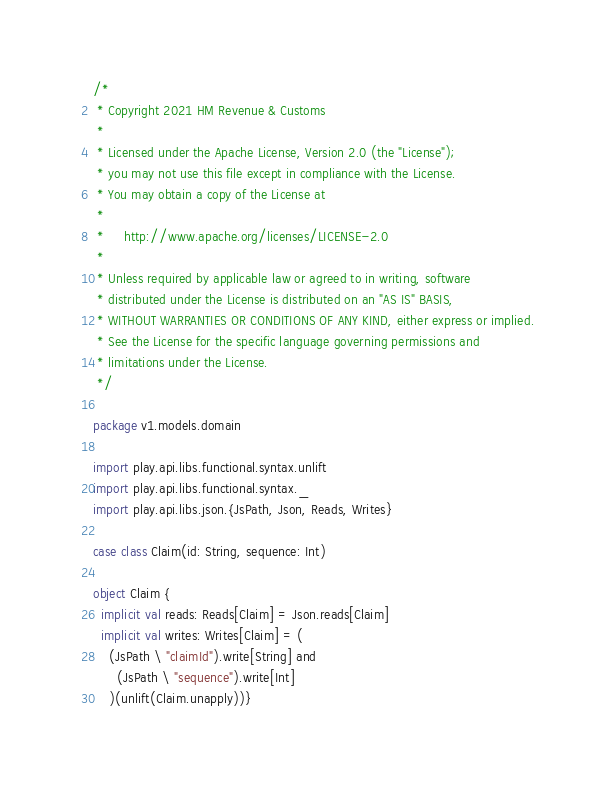Convert code to text. <code><loc_0><loc_0><loc_500><loc_500><_Scala_>/*
 * Copyright 2021 HM Revenue & Customs
 *
 * Licensed under the Apache License, Version 2.0 (the "License");
 * you may not use this file except in compliance with the License.
 * You may obtain a copy of the License at
 *
 *     http://www.apache.org/licenses/LICENSE-2.0
 *
 * Unless required by applicable law or agreed to in writing, software
 * distributed under the License is distributed on an "AS IS" BASIS,
 * WITHOUT WARRANTIES OR CONDITIONS OF ANY KIND, either express or implied.
 * See the License for the specific language governing permissions and
 * limitations under the License.
 */

package v1.models.domain

import play.api.libs.functional.syntax.unlift
import play.api.libs.functional.syntax._
import play.api.libs.json.{JsPath, Json, Reads, Writes}

case class Claim(id: String, sequence: Int)

object Claim {
  implicit val reads: Reads[Claim] = Json.reads[Claim]
  implicit val writes: Writes[Claim] = (
    (JsPath \ "claimId").write[String] and
      (JsPath \ "sequence").write[Int]
    )(unlift(Claim.unapply))}</code> 